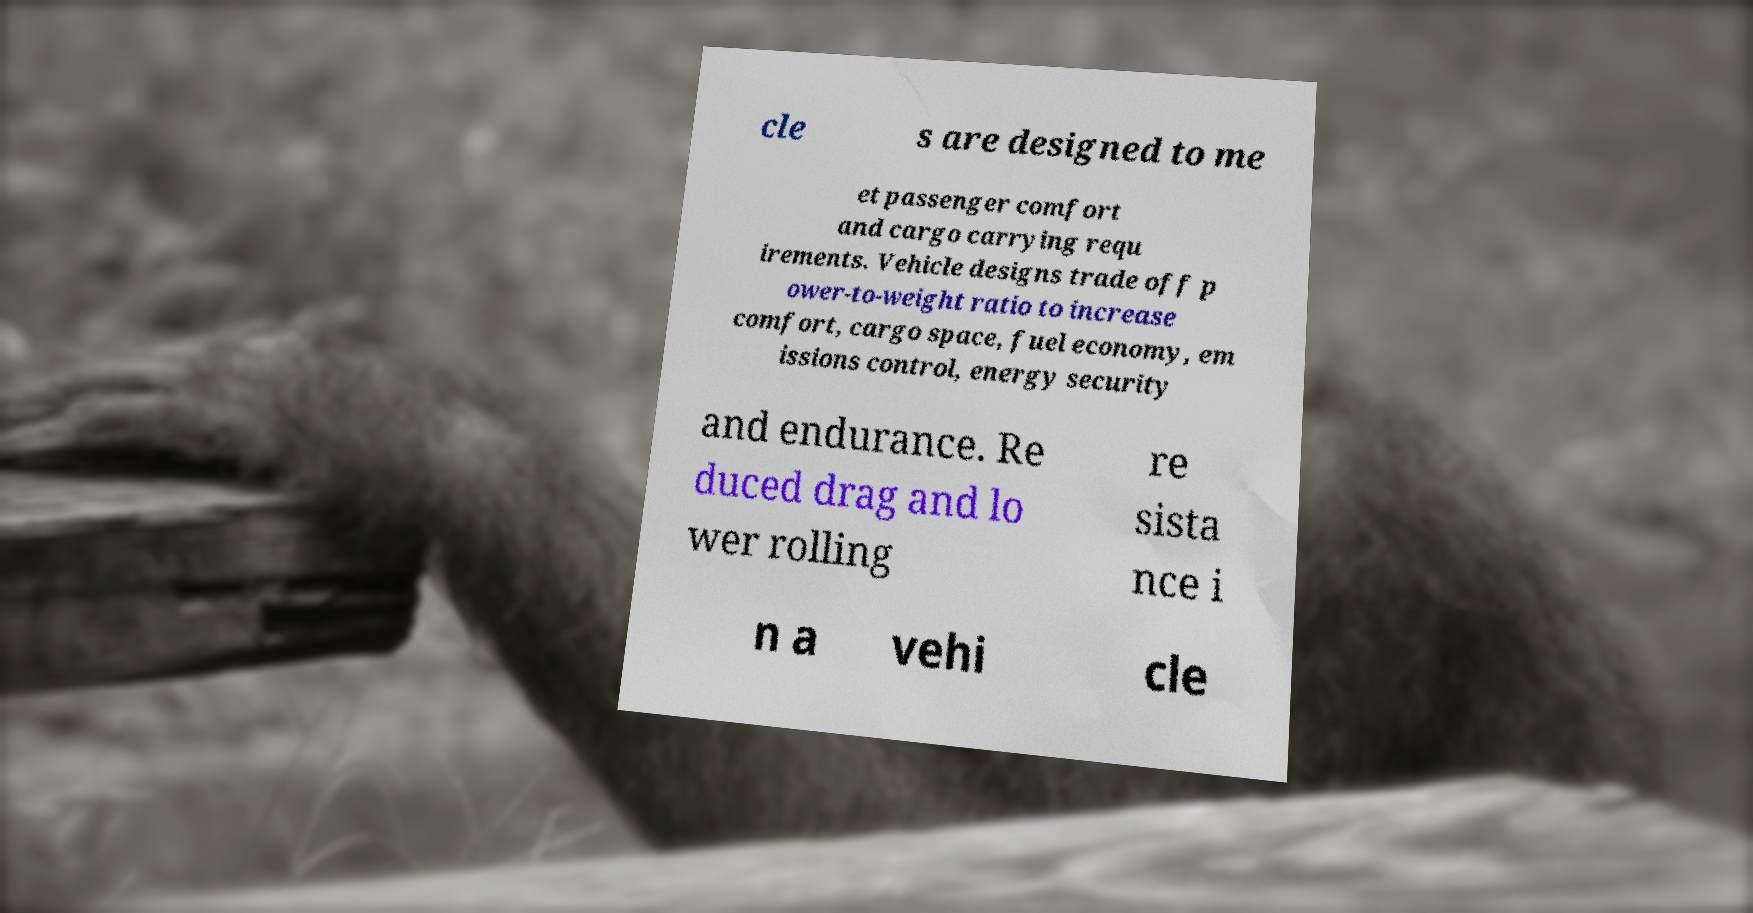I need the written content from this picture converted into text. Can you do that? cle s are designed to me et passenger comfort and cargo carrying requ irements. Vehicle designs trade off p ower-to-weight ratio to increase comfort, cargo space, fuel economy, em issions control, energy security and endurance. Re duced drag and lo wer rolling re sista nce i n a vehi cle 